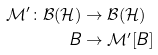Convert formula to latex. <formula><loc_0><loc_0><loc_500><loc_500>\mathcal { M } ^ { \prime } \colon \mathcal { B } ( \mathcal { H } ) & \rightarrow \mathcal { B } ( \mathcal { H } ) \\ B & \rightarrow \mathcal { M } ^ { \prime } [ B ]</formula> 